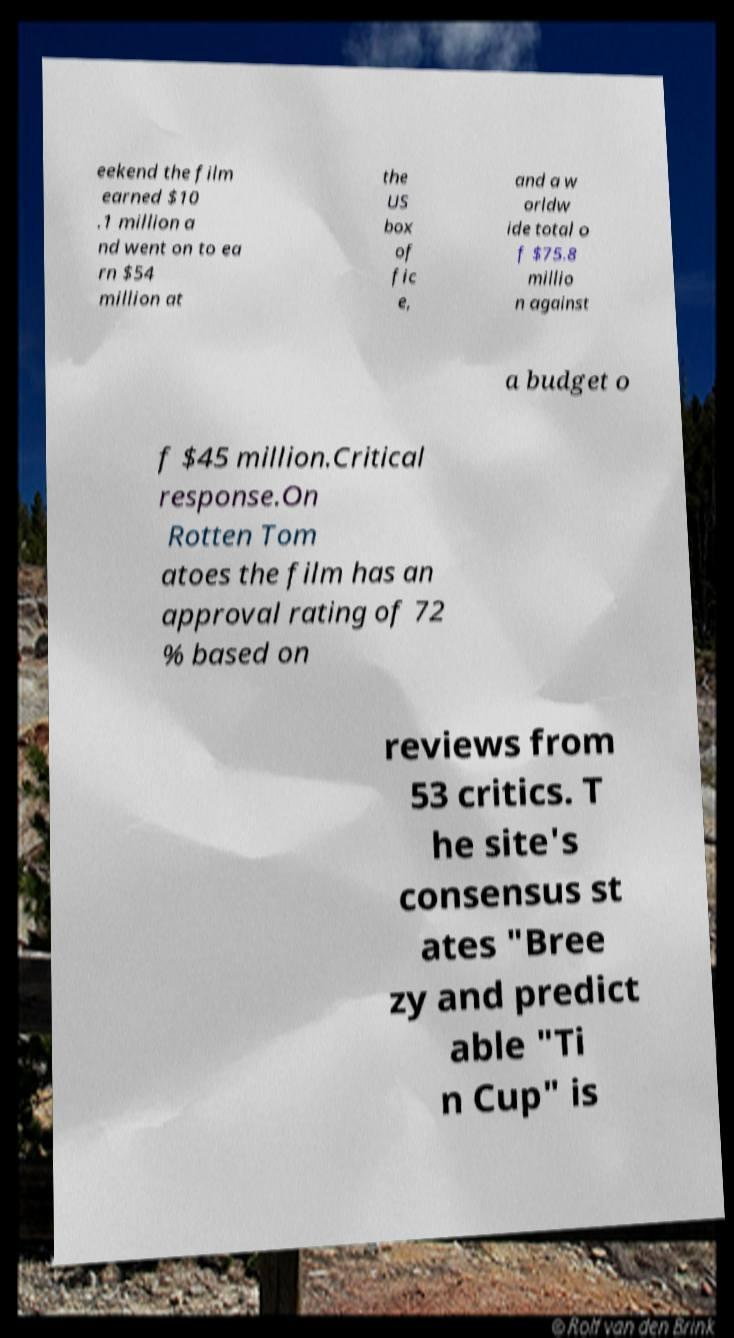Please read and relay the text visible in this image. What does it say? eekend the film earned $10 .1 million a nd went on to ea rn $54 million at the US box of fic e, and a w orldw ide total o f $75.8 millio n against a budget o f $45 million.Critical response.On Rotten Tom atoes the film has an approval rating of 72 % based on reviews from 53 critics. T he site's consensus st ates "Bree zy and predict able "Ti n Cup" is 